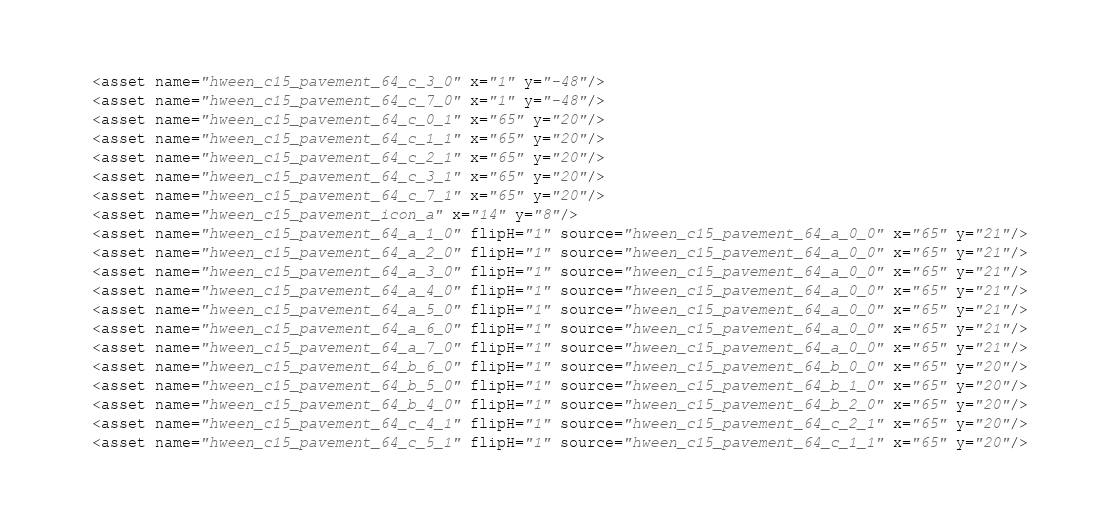Convert code to text. <code><loc_0><loc_0><loc_500><loc_500><_XML_>  <asset name="hween_c15_pavement_64_c_3_0" x="1" y="-48"/>
  <asset name="hween_c15_pavement_64_c_7_0" x="1" y="-48"/>
  <asset name="hween_c15_pavement_64_c_0_1" x="65" y="20"/>
  <asset name="hween_c15_pavement_64_c_1_1" x="65" y="20"/>
  <asset name="hween_c15_pavement_64_c_2_1" x="65" y="20"/>
  <asset name="hween_c15_pavement_64_c_3_1" x="65" y="20"/>
  <asset name="hween_c15_pavement_64_c_7_1" x="65" y="20"/>
  <asset name="hween_c15_pavement_icon_a" x="14" y="8"/>
  <asset name="hween_c15_pavement_64_a_1_0" flipH="1" source="hween_c15_pavement_64_a_0_0" x="65" y="21"/>
  <asset name="hween_c15_pavement_64_a_2_0" flipH="1" source="hween_c15_pavement_64_a_0_0" x="65" y="21"/>
  <asset name="hween_c15_pavement_64_a_3_0" flipH="1" source="hween_c15_pavement_64_a_0_0" x="65" y="21"/>
  <asset name="hween_c15_pavement_64_a_4_0" flipH="1" source="hween_c15_pavement_64_a_0_0" x="65" y="21"/>
  <asset name="hween_c15_pavement_64_a_5_0" flipH="1" source="hween_c15_pavement_64_a_0_0" x="65" y="21"/>
  <asset name="hween_c15_pavement_64_a_6_0" flipH="1" source="hween_c15_pavement_64_a_0_0" x="65" y="21"/>
  <asset name="hween_c15_pavement_64_a_7_0" flipH="1" source="hween_c15_pavement_64_a_0_0" x="65" y="21"/>
  <asset name="hween_c15_pavement_64_b_6_0" flipH="1" source="hween_c15_pavement_64_b_0_0" x="65" y="20"/>
  <asset name="hween_c15_pavement_64_b_5_0" flipH="1" source="hween_c15_pavement_64_b_1_0" x="65" y="20"/>
  <asset name="hween_c15_pavement_64_b_4_0" flipH="1" source="hween_c15_pavement_64_b_2_0" x="65" y="20"/>
  <asset name="hween_c15_pavement_64_c_4_1" flipH="1" source="hween_c15_pavement_64_c_2_1" x="65" y="20"/>
  <asset name="hween_c15_pavement_64_c_5_1" flipH="1" source="hween_c15_pavement_64_c_1_1" x="65" y="20"/></code> 